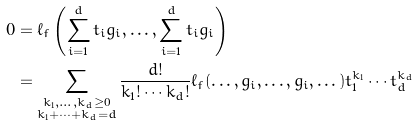Convert formula to latex. <formula><loc_0><loc_0><loc_500><loc_500>0 & = \ell _ { f } \left ( \sum _ { i = 1 } ^ { d } t _ { i } g _ { i } , \dots , \sum _ { i = 1 } ^ { d } t _ { i } g _ { i } \right ) \\ & = \sum _ { \substack { k _ { 1 } , \dots , k _ { d } \geq 0 \\ k _ { 1 } + \cdots + k _ { d } = d } } \frac { d ! } { k _ { 1 } ! \cdots k _ { d } ! } \ell _ { f } ( \dots , g _ { i } , \dots , g _ { i } , \dots ) t _ { 1 } ^ { k _ { 1 } } \cdots t _ { d } ^ { k _ { d } }</formula> 